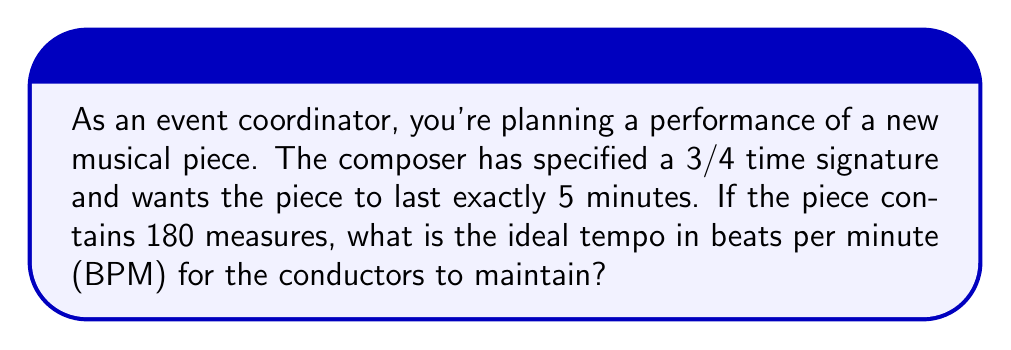Can you answer this question? Let's approach this step-by-step:

1) First, we need to understand what the time signature 3/4 means:
   - There are 3 beats per measure
   - A quarter note gets one beat

2) Now, let's calculate the total number of beats in the piece:
   - Number of measures = 180
   - Beats per measure = 3
   - Total beats = $180 \times 3 = 540$ beats

3) We know the piece should last exactly 5 minutes. Let's convert this to seconds:
   - Duration = $5 \times 60 = 300$ seconds

4) To find the tempo in beats per minute (BPM), we need to determine how many beats occur in one minute. We can set up the following proportion:

   $$\frac{540 \text{ beats}}{300 \text{ seconds}} = \frac{x \text{ beats}}{60 \text{ seconds}}$$

5) Cross multiply:
   $$540 \times 60 = 300x$$

6) Solve for x:
   $$x = \frac{540 \times 60}{300} = 108$$

Therefore, the ideal tempo is 108 beats per minute.
Answer: 108 BPM 